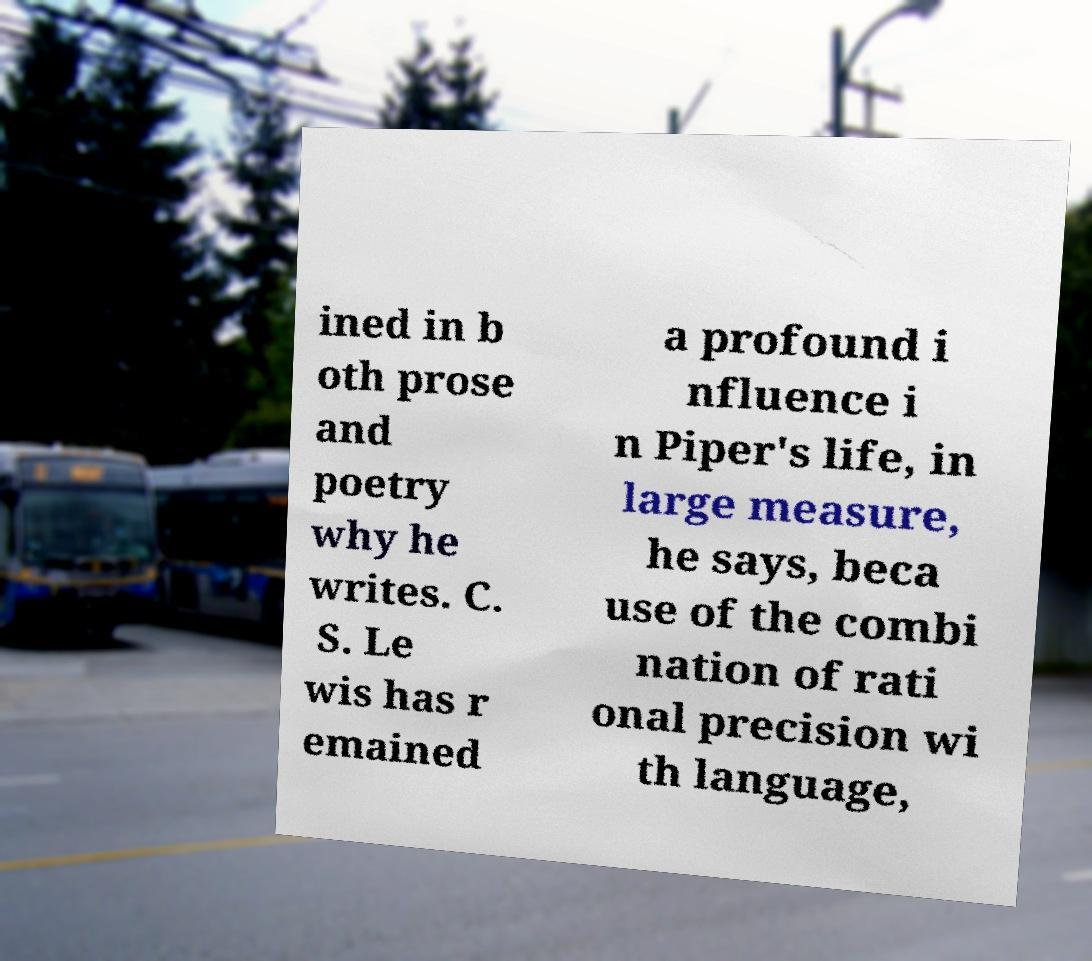Can you read and provide the text displayed in the image?This photo seems to have some interesting text. Can you extract and type it out for me? ined in b oth prose and poetry why he writes. C. S. Le wis has r emained a profound i nfluence i n Piper's life, in large measure, he says, beca use of the combi nation of rati onal precision wi th language, 